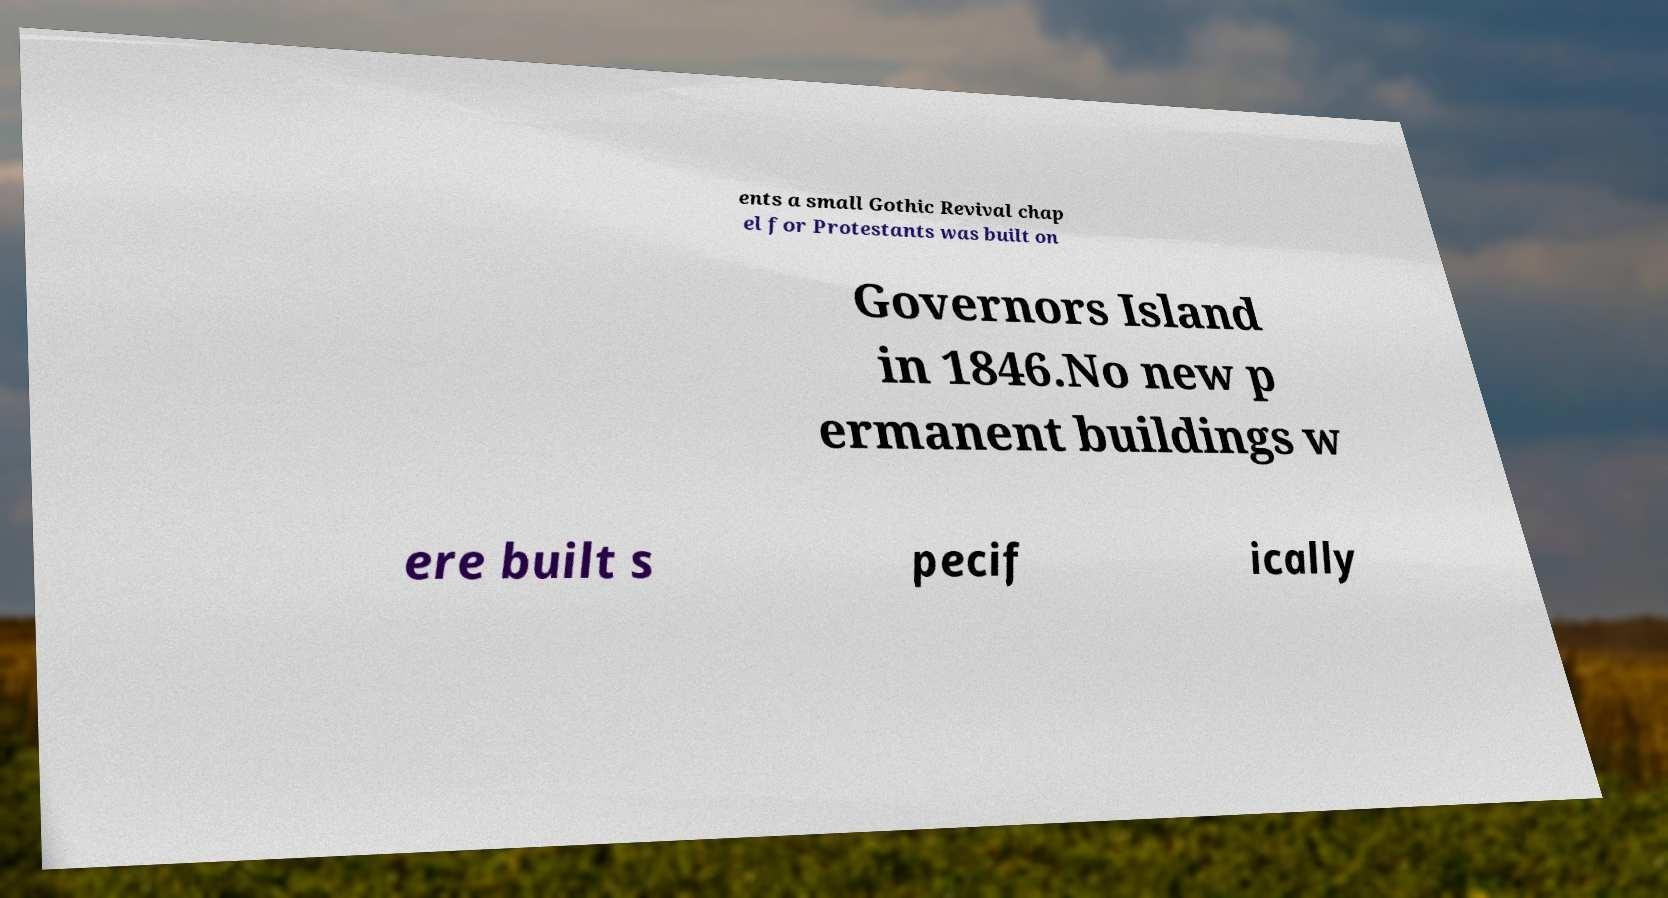I need the written content from this picture converted into text. Can you do that? ents a small Gothic Revival chap el for Protestants was built on Governors Island in 1846.No new p ermanent buildings w ere built s pecif ically 